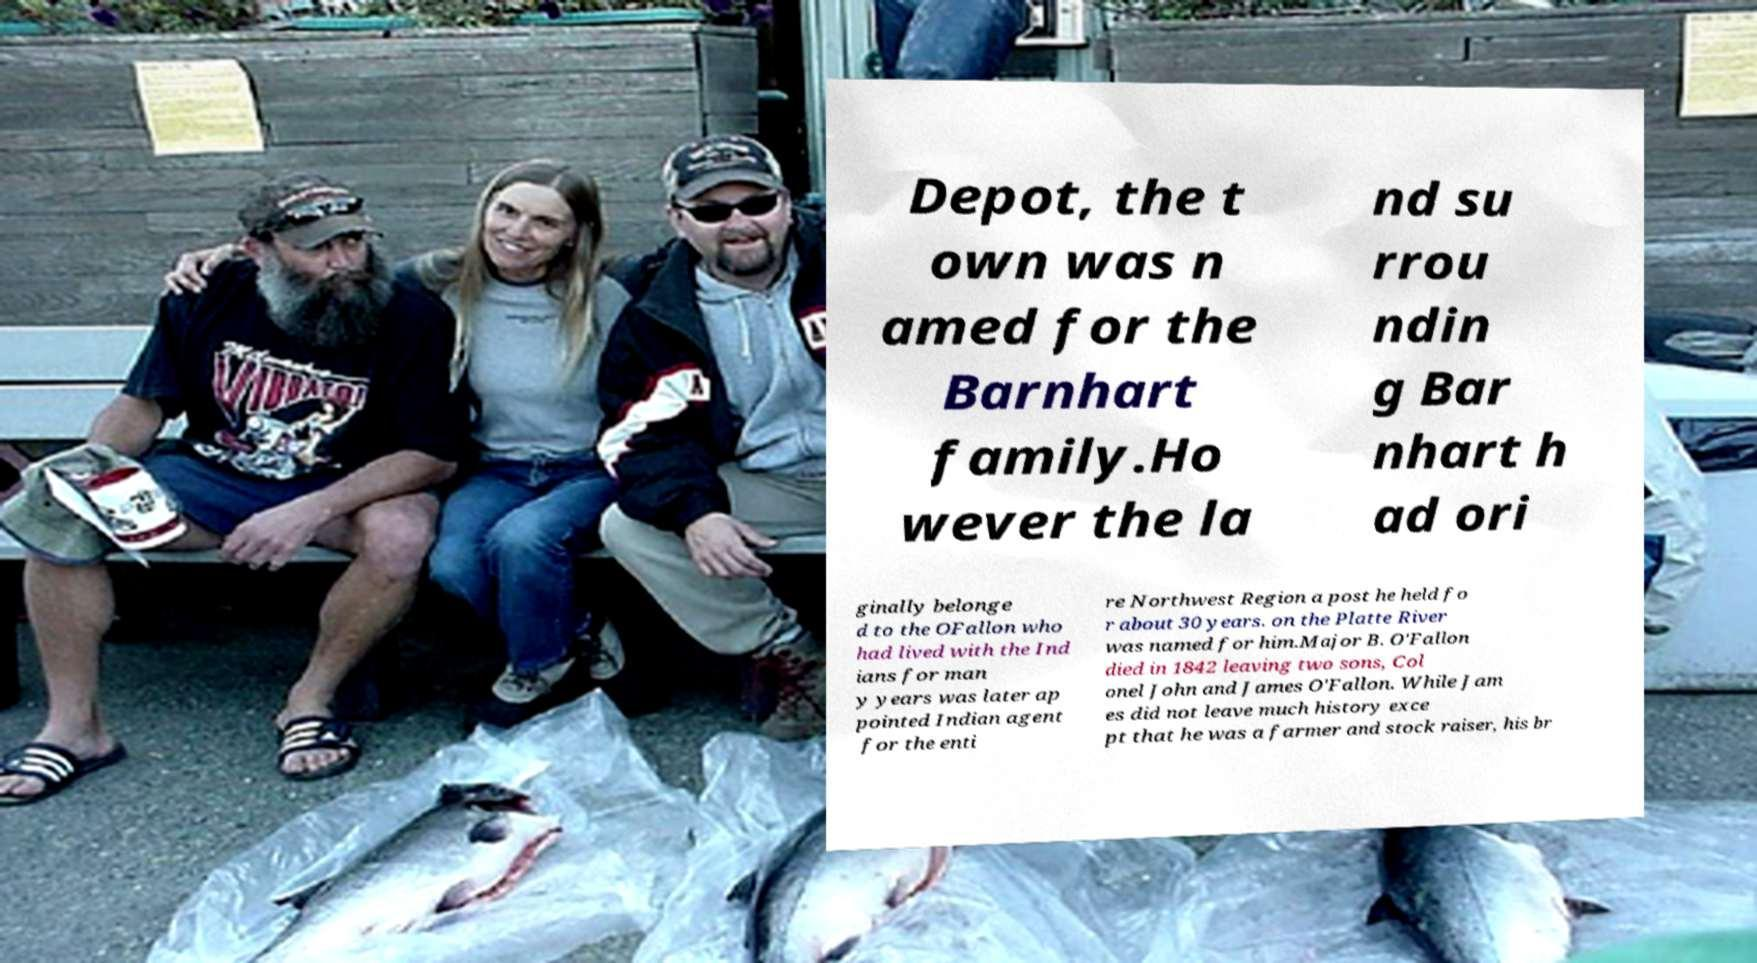Please identify and transcribe the text found in this image. Depot, the t own was n amed for the Barnhart family.Ho wever the la nd su rrou ndin g Bar nhart h ad ori ginally belonge d to the OFallon who had lived with the Ind ians for man y years was later ap pointed Indian agent for the enti re Northwest Region a post he held fo r about 30 years. on the Platte River was named for him.Major B. O'Fallon died in 1842 leaving two sons, Col onel John and James O'Fallon. While Jam es did not leave much history exce pt that he was a farmer and stock raiser, his br 